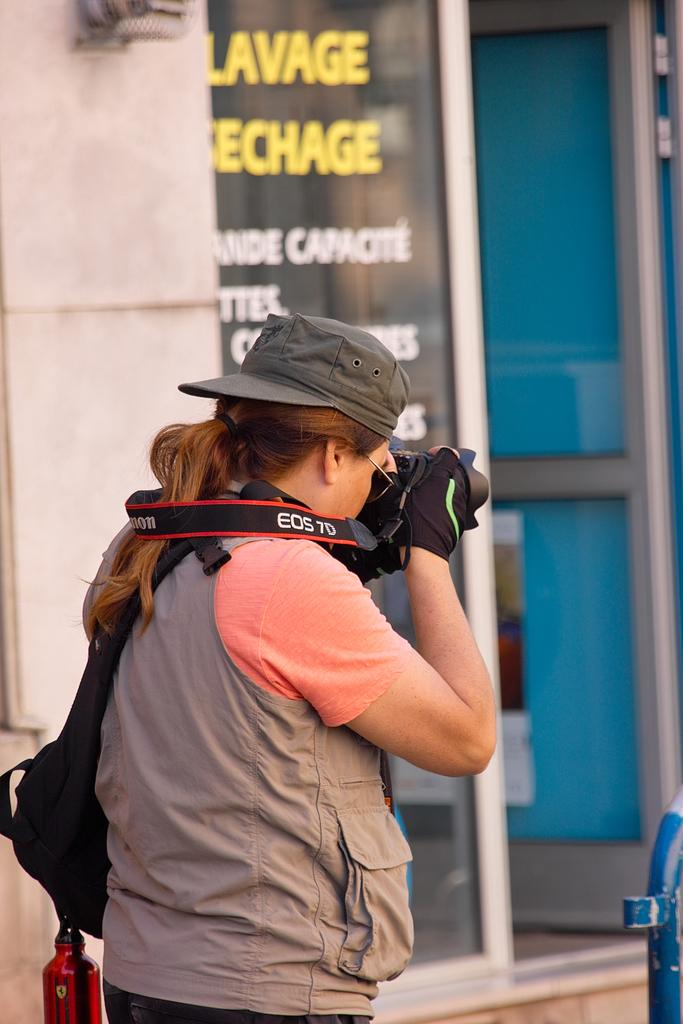What is one of the main features in the image? There is a door in the image. What else can be seen on the wall in the image? There is a poster in the image. What architectural element is present in the image? There is a pillar in the image. What is the woman in the image doing? The woman appears to be taking a snap, as she is holding a camera. What accessories is the woman wearing in the image? The woman is wearing a cap and goggles. How many ducks are visible in the image? There are no ducks present in the image. What type of quiver is the woman using to hold her camera? The woman is not using a quiver to hold her camera; she is simply holding it in her hands. 